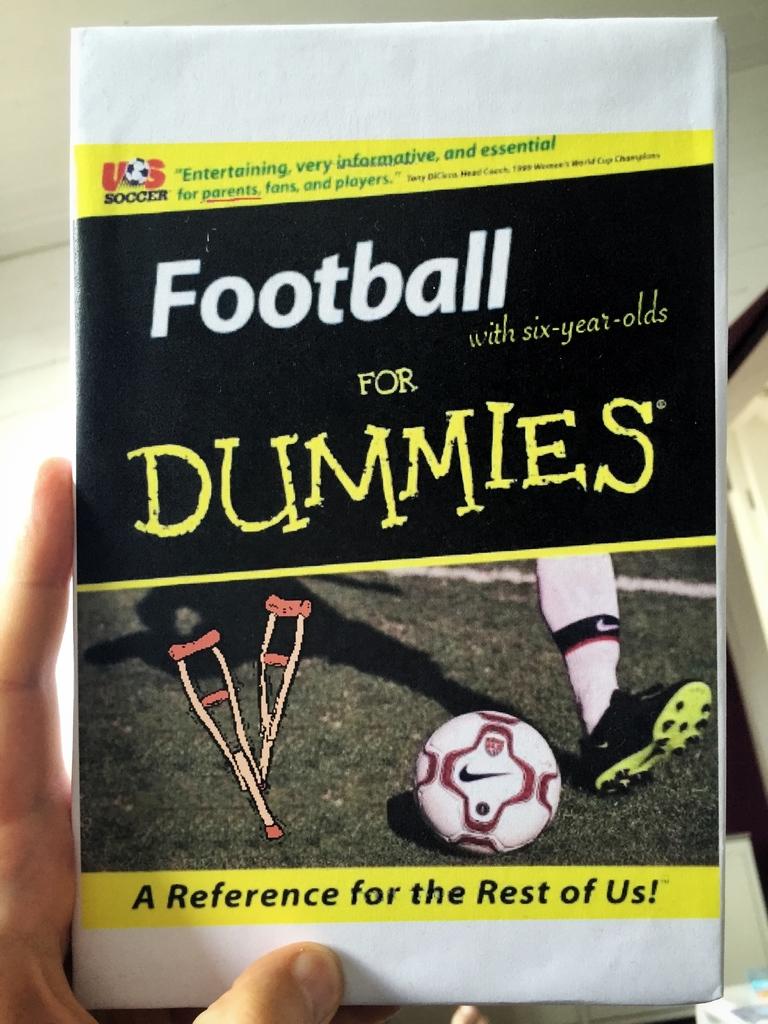What is this book suppose to help someone learn?
Offer a very short reply. Football. 